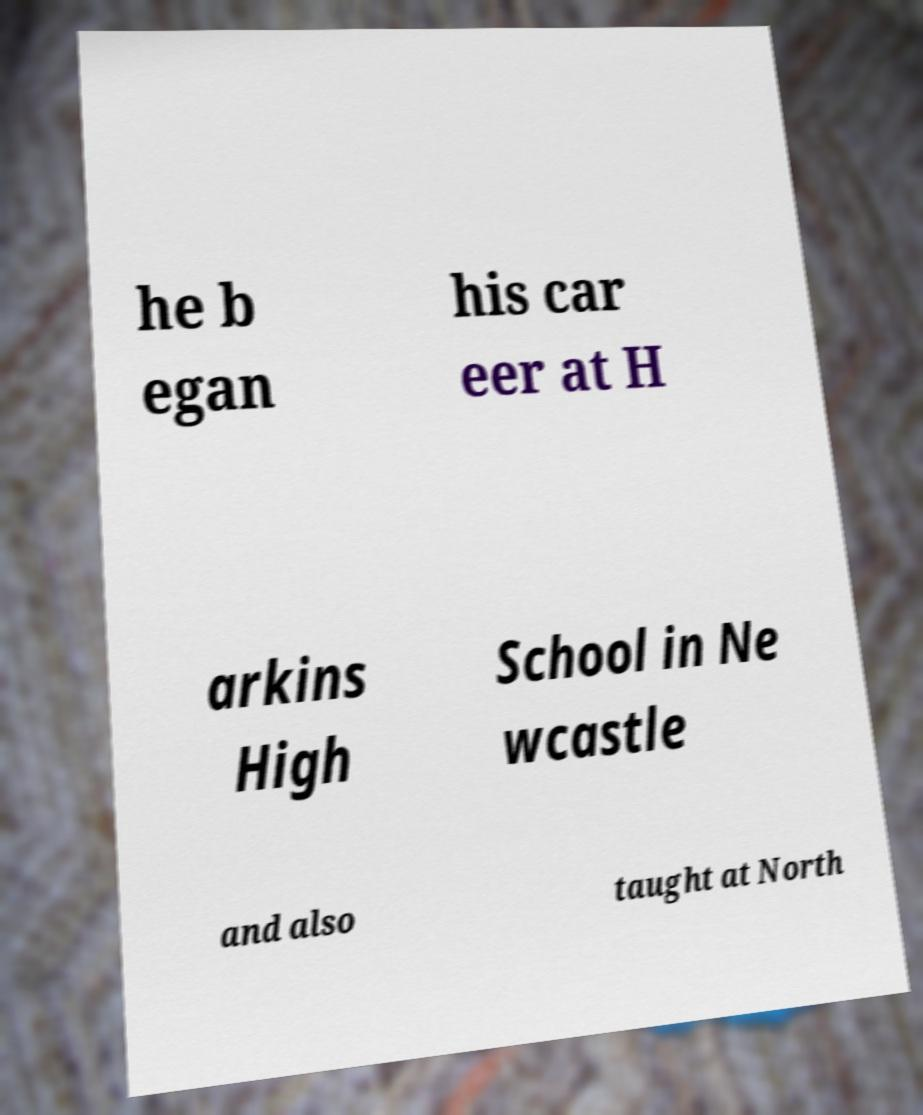Please read and relay the text visible in this image. What does it say? he b egan his car eer at H arkins High School in Ne wcastle and also taught at North 